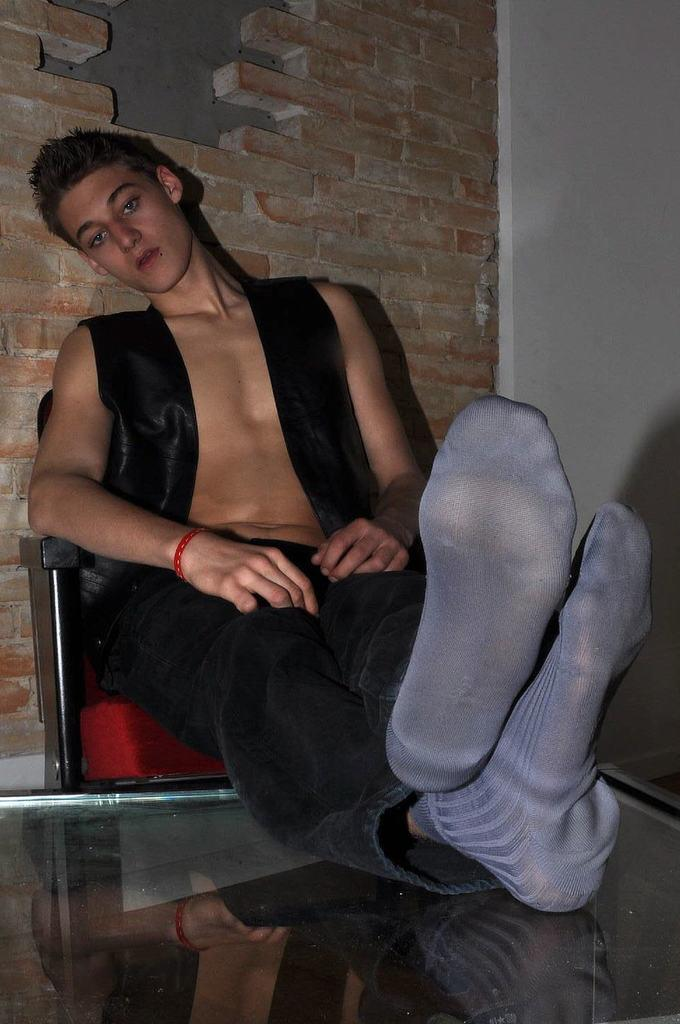What is the main subject in the center of the image? There is a person sitting on a chair in the center of the image. What object is in front of the person? There is a table-like object in front of the person. What can be seen in the background of the image? There is a wall in the background of the image. How many cakes are on the table in the image? There is no mention of cakes in the image; the table-like object is not described as having any cakes on it. 